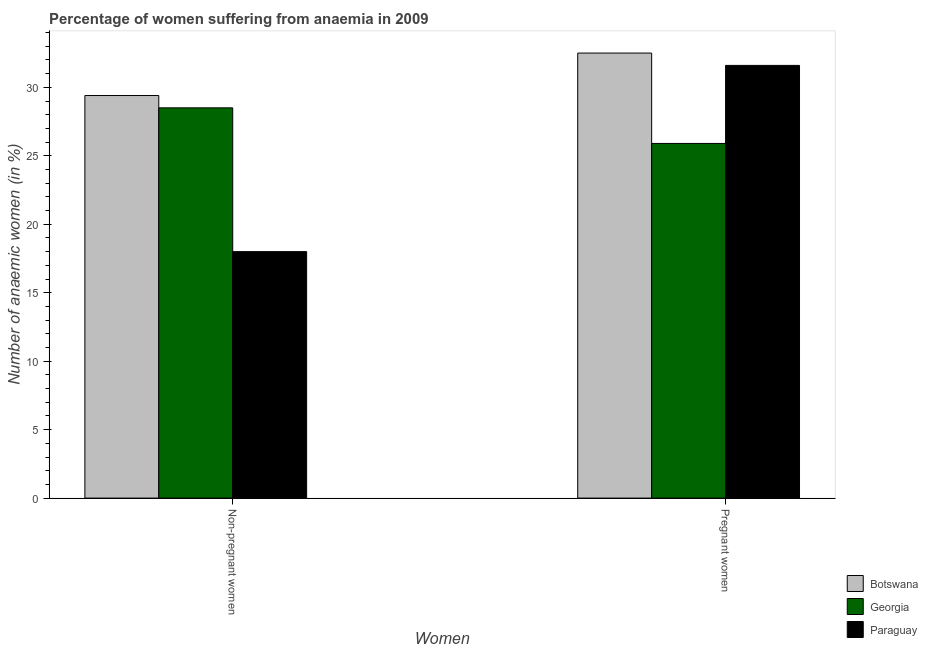How many different coloured bars are there?
Provide a short and direct response. 3. How many groups of bars are there?
Keep it short and to the point. 2. How many bars are there on the 1st tick from the left?
Offer a terse response. 3. How many bars are there on the 1st tick from the right?
Offer a very short reply. 3. What is the label of the 1st group of bars from the left?
Offer a terse response. Non-pregnant women. What is the percentage of pregnant anaemic women in Georgia?
Offer a very short reply. 25.9. Across all countries, what is the maximum percentage of non-pregnant anaemic women?
Give a very brief answer. 29.4. Across all countries, what is the minimum percentage of pregnant anaemic women?
Your response must be concise. 25.9. In which country was the percentage of pregnant anaemic women maximum?
Offer a terse response. Botswana. In which country was the percentage of pregnant anaemic women minimum?
Your response must be concise. Georgia. What is the total percentage of non-pregnant anaemic women in the graph?
Keep it short and to the point. 75.9. What is the difference between the percentage of non-pregnant anaemic women in Botswana and that in Paraguay?
Make the answer very short. 11.4. What is the average percentage of non-pregnant anaemic women per country?
Make the answer very short. 25.3. What is the difference between the percentage of pregnant anaemic women and percentage of non-pregnant anaemic women in Paraguay?
Your response must be concise. 13.6. In how many countries, is the percentage of non-pregnant anaemic women greater than 30 %?
Offer a very short reply. 0. What is the ratio of the percentage of non-pregnant anaemic women in Botswana to that in Paraguay?
Your answer should be compact. 1.63. Is the percentage of pregnant anaemic women in Botswana less than that in Paraguay?
Your answer should be very brief. No. In how many countries, is the percentage of non-pregnant anaemic women greater than the average percentage of non-pregnant anaemic women taken over all countries?
Keep it short and to the point. 2. What does the 3rd bar from the left in Pregnant women represents?
Offer a very short reply. Paraguay. What does the 3rd bar from the right in Non-pregnant women represents?
Your response must be concise. Botswana. How many bars are there?
Provide a succinct answer. 6. How many countries are there in the graph?
Make the answer very short. 3. What is the difference between two consecutive major ticks on the Y-axis?
Your response must be concise. 5. Are the values on the major ticks of Y-axis written in scientific E-notation?
Offer a very short reply. No. Does the graph contain any zero values?
Offer a terse response. No. How many legend labels are there?
Your response must be concise. 3. What is the title of the graph?
Ensure brevity in your answer.  Percentage of women suffering from anaemia in 2009. Does "Guinea-Bissau" appear as one of the legend labels in the graph?
Your answer should be compact. No. What is the label or title of the X-axis?
Offer a very short reply. Women. What is the label or title of the Y-axis?
Ensure brevity in your answer.  Number of anaemic women (in %). What is the Number of anaemic women (in %) in Botswana in Non-pregnant women?
Provide a succinct answer. 29.4. What is the Number of anaemic women (in %) of Botswana in Pregnant women?
Provide a succinct answer. 32.5. What is the Number of anaemic women (in %) in Georgia in Pregnant women?
Your answer should be very brief. 25.9. What is the Number of anaemic women (in %) of Paraguay in Pregnant women?
Provide a short and direct response. 31.6. Across all Women, what is the maximum Number of anaemic women (in %) of Botswana?
Offer a terse response. 32.5. Across all Women, what is the maximum Number of anaemic women (in %) in Georgia?
Your answer should be very brief. 28.5. Across all Women, what is the maximum Number of anaemic women (in %) of Paraguay?
Provide a succinct answer. 31.6. Across all Women, what is the minimum Number of anaemic women (in %) of Botswana?
Your answer should be compact. 29.4. Across all Women, what is the minimum Number of anaemic women (in %) of Georgia?
Keep it short and to the point. 25.9. Across all Women, what is the minimum Number of anaemic women (in %) in Paraguay?
Offer a terse response. 18. What is the total Number of anaemic women (in %) of Botswana in the graph?
Your answer should be very brief. 61.9. What is the total Number of anaemic women (in %) in Georgia in the graph?
Offer a terse response. 54.4. What is the total Number of anaemic women (in %) of Paraguay in the graph?
Offer a very short reply. 49.6. What is the difference between the Number of anaemic women (in %) of Botswana in Non-pregnant women and that in Pregnant women?
Your answer should be very brief. -3.1. What is the difference between the Number of anaemic women (in %) in Georgia in Non-pregnant women and that in Pregnant women?
Offer a very short reply. 2.6. What is the difference between the Number of anaemic women (in %) in Botswana in Non-pregnant women and the Number of anaemic women (in %) in Georgia in Pregnant women?
Offer a very short reply. 3.5. What is the average Number of anaemic women (in %) of Botswana per Women?
Provide a short and direct response. 30.95. What is the average Number of anaemic women (in %) of Georgia per Women?
Give a very brief answer. 27.2. What is the average Number of anaemic women (in %) in Paraguay per Women?
Your answer should be compact. 24.8. What is the difference between the Number of anaemic women (in %) of Botswana and Number of anaemic women (in %) of Georgia in Pregnant women?
Offer a very short reply. 6.6. What is the ratio of the Number of anaemic women (in %) of Botswana in Non-pregnant women to that in Pregnant women?
Your response must be concise. 0.9. What is the ratio of the Number of anaemic women (in %) of Georgia in Non-pregnant women to that in Pregnant women?
Offer a very short reply. 1.1. What is the ratio of the Number of anaemic women (in %) of Paraguay in Non-pregnant women to that in Pregnant women?
Provide a short and direct response. 0.57. What is the difference between the highest and the second highest Number of anaemic women (in %) in Botswana?
Keep it short and to the point. 3.1. What is the difference between the highest and the second highest Number of anaemic women (in %) of Georgia?
Provide a succinct answer. 2.6. What is the difference between the highest and the second highest Number of anaemic women (in %) of Paraguay?
Give a very brief answer. 13.6. What is the difference between the highest and the lowest Number of anaemic women (in %) in Botswana?
Keep it short and to the point. 3.1. 